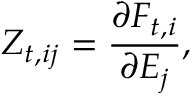<formula> <loc_0><loc_0><loc_500><loc_500>Z _ { t , i j } = \frac { \partial F _ { t , i } } { \partial E _ { j } } ,</formula> 